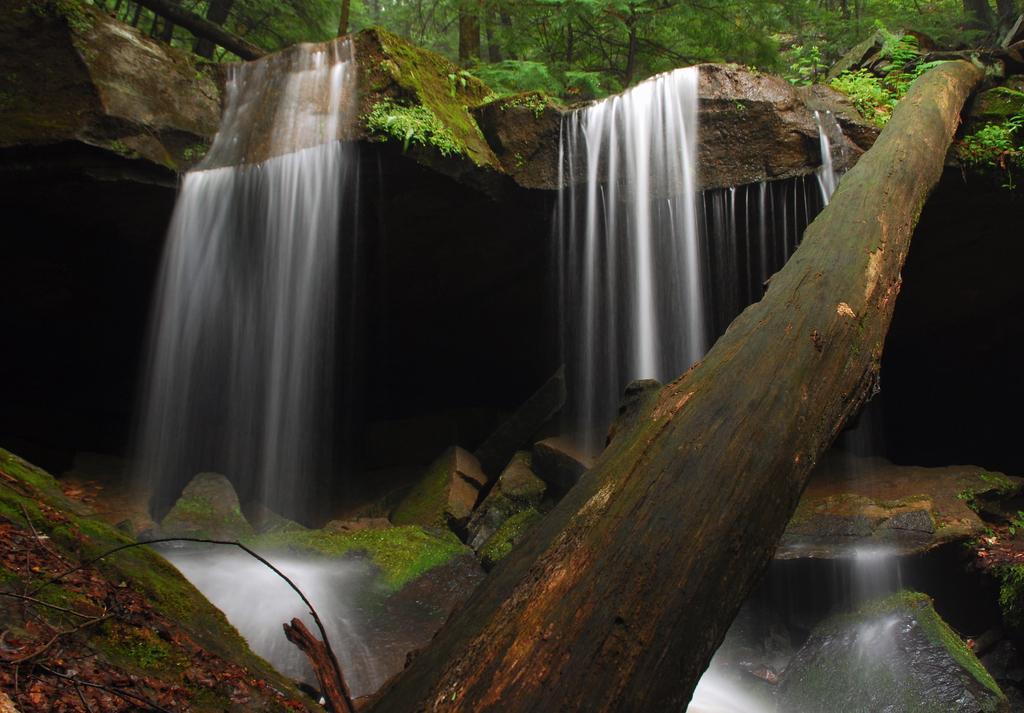Could you give a brief overview of what you see in this image? This picture is clicked outside. In the foreground we can see a water body and a trunk of a tree like object and we can see the rocks, and in the center we can see the waterfalls, some portion of green grass and we can see the plants and trees and the rocks. 